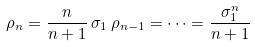Convert formula to latex. <formula><loc_0><loc_0><loc_500><loc_500>\rho _ { n } = \frac { n } { n + 1 } \, \sigma _ { 1 } \, \rho _ { n - 1 } = \dots = \frac { \sigma _ { 1 } ^ { n } } { n + 1 }</formula> 